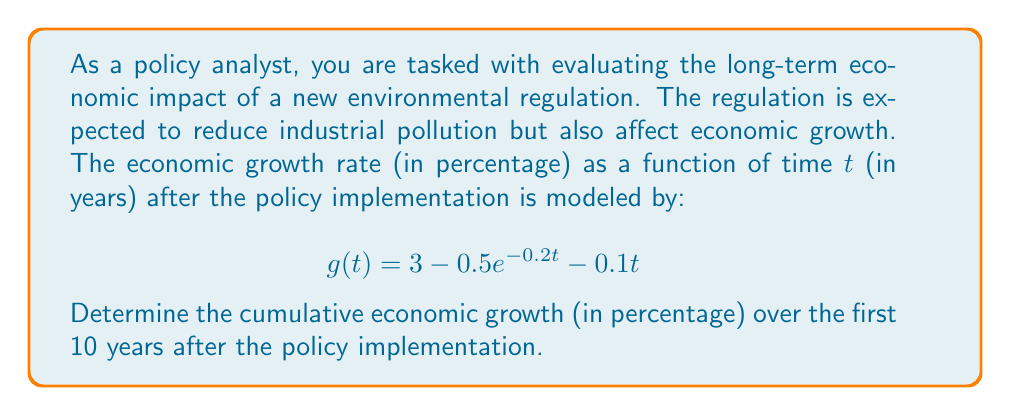Help me with this question. To solve this problem, we need to integrate the growth rate function over the given time period. The cumulative growth is the area under the curve of the growth rate function from t = 0 to t = 10.

1) Set up the definite integral:

   $$\int_0^{10} (3 - 0.5e^{-0.2t} - 0.1t) dt$$

2) Integrate each term separately:

   a) $\int 3 dt = 3t$
   
   b) $\int -0.5e^{-0.2t} dt = 2.5e^{-0.2t}$
   
   c) $\int -0.1t dt = -0.05t^2$

3) Apply the fundamental theorem of calculus:

   $$\left[3t + 2.5e^{-0.2t} - 0.05t^2\right]_0^{10}$$

4) Evaluate the expression at t = 10 and t = 0:

   At t = 10: $30 + 2.5e^{-2} - 5$
   At t = 0: $0 + 2.5 - 0$

5) Subtract the value at t = 0 from the value at t = 10:

   $(30 + 2.5e^{-2} - 5) - (2.5)$

6) Simplify:

   $25 + 2.5e^{-2} - 2.5 = 22.5 + 2.5e^{-2}$

7) Calculate the final value:

   $22.5 + 2.5 * 0.1353 = 22.8383$

Therefore, the cumulative economic growth over the first 10 years is approximately 22.84%.
Answer: 22.84% 